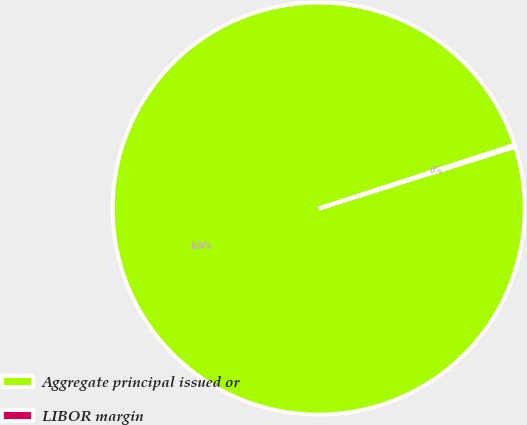Convert chart. <chart><loc_0><loc_0><loc_500><loc_500><pie_chart><fcel>Aggregate principal issued or<fcel>LIBOR margin<nl><fcel>99.84%<fcel>0.16%<nl></chart> 